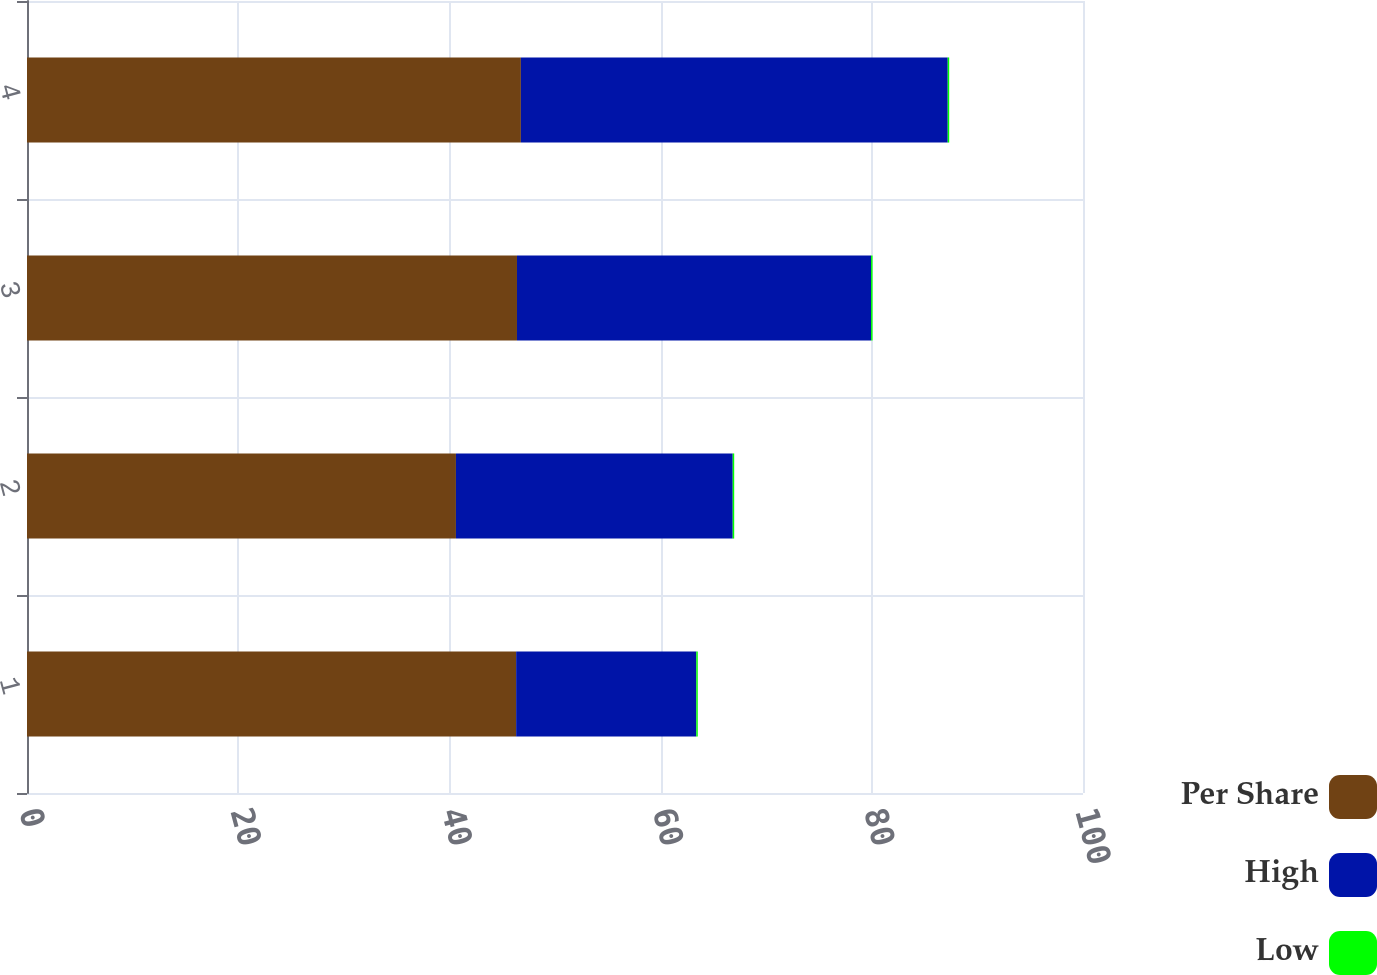Convert chart. <chart><loc_0><loc_0><loc_500><loc_500><stacked_bar_chart><ecel><fcel>1<fcel>2<fcel>3<fcel>4<nl><fcel>Per Share<fcel>46.32<fcel>40.62<fcel>46.4<fcel>46.77<nl><fcel>High<fcel>17.06<fcel>26.21<fcel>33.53<fcel>40.42<nl><fcel>Low<fcel>0.14<fcel>0.14<fcel>0.14<fcel>0.14<nl></chart> 